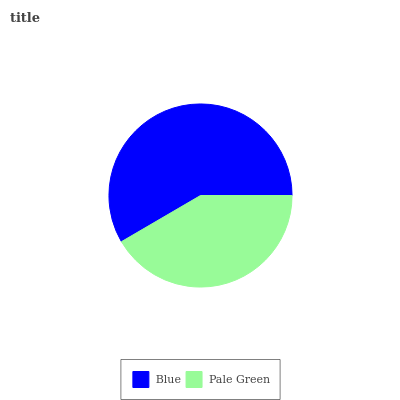Is Pale Green the minimum?
Answer yes or no. Yes. Is Blue the maximum?
Answer yes or no. Yes. Is Pale Green the maximum?
Answer yes or no. No. Is Blue greater than Pale Green?
Answer yes or no. Yes. Is Pale Green less than Blue?
Answer yes or no. Yes. Is Pale Green greater than Blue?
Answer yes or no. No. Is Blue less than Pale Green?
Answer yes or no. No. Is Blue the high median?
Answer yes or no. Yes. Is Pale Green the low median?
Answer yes or no. Yes. Is Pale Green the high median?
Answer yes or no. No. Is Blue the low median?
Answer yes or no. No. 